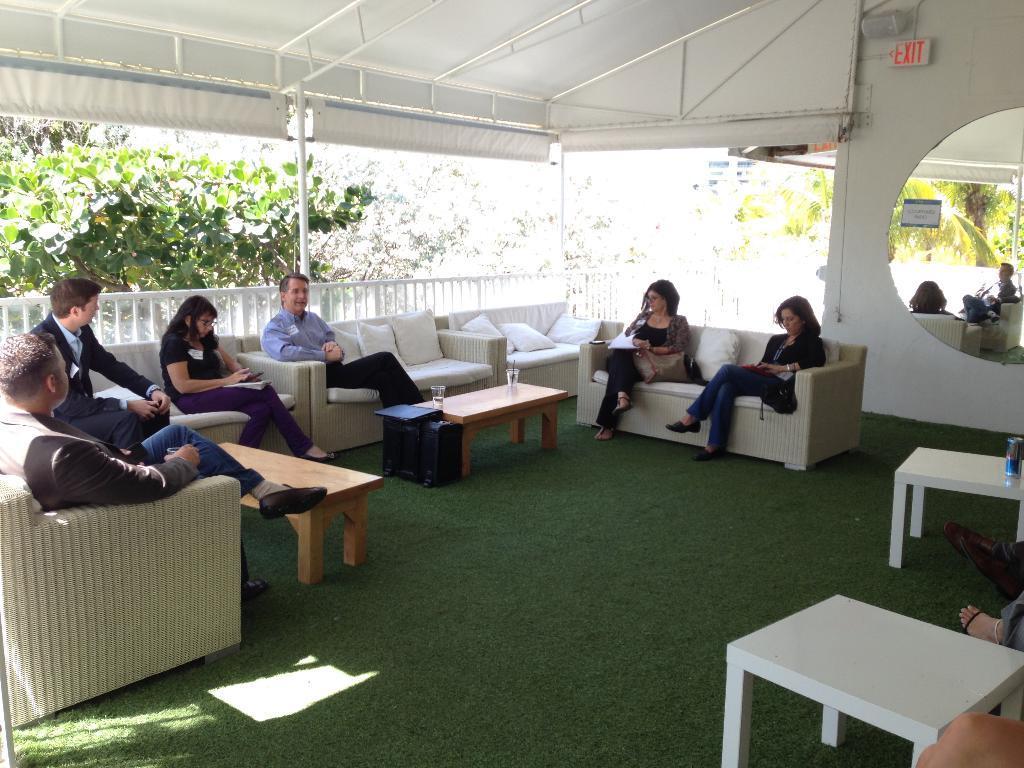How would you summarize this image in a sentence or two? In the picture there are some sofas and a group of people are sitting on them,there are two tables in front of the sofas and behind the people there is a white color fencing and behind the fencing there are many trees and in the right side there is a mirror. 